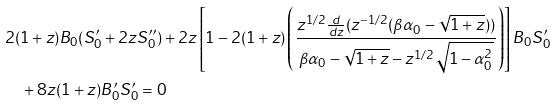Convert formula to latex. <formula><loc_0><loc_0><loc_500><loc_500>& 2 ( 1 + z ) B _ { 0 } ( S _ { 0 } ^ { \prime } + 2 z S _ { 0 } ^ { \prime \prime } ) + 2 z \left [ 1 - 2 ( 1 + z ) \left ( \frac { z ^ { 1 / 2 } \frac { d } { d z } ( z ^ { - 1 / 2 } ( \beta \alpha _ { 0 } - \sqrt { 1 + z } ) ) } { \beta \alpha _ { 0 } - \sqrt { 1 + z } - z ^ { 1 / 2 } \sqrt { 1 - \alpha _ { 0 } ^ { 2 } } } \right ) \right ] B _ { 0 } S _ { 0 } ^ { \prime } \\ & \quad + 8 z ( 1 + z ) B _ { 0 } ^ { \prime } S _ { 0 } ^ { \prime } = 0</formula> 